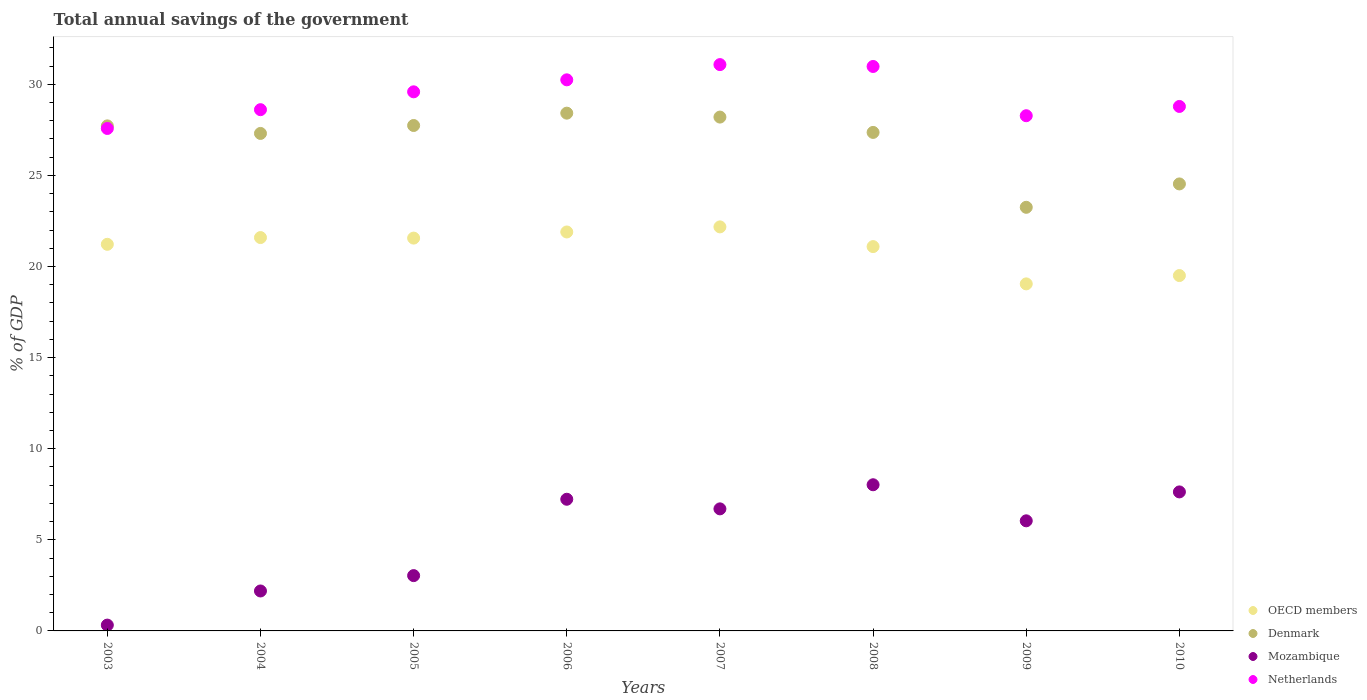How many different coloured dotlines are there?
Your response must be concise. 4. Is the number of dotlines equal to the number of legend labels?
Ensure brevity in your answer.  Yes. What is the total annual savings of the government in Netherlands in 2008?
Give a very brief answer. 30.98. Across all years, what is the maximum total annual savings of the government in OECD members?
Offer a very short reply. 22.17. Across all years, what is the minimum total annual savings of the government in Mozambique?
Offer a terse response. 0.32. What is the total total annual savings of the government in OECD members in the graph?
Your response must be concise. 168.07. What is the difference between the total annual savings of the government in Netherlands in 2004 and that in 2010?
Your answer should be compact. -0.18. What is the difference between the total annual savings of the government in Netherlands in 2006 and the total annual savings of the government in Mozambique in 2009?
Your answer should be very brief. 24.2. What is the average total annual savings of the government in OECD members per year?
Your answer should be compact. 21.01. In the year 2007, what is the difference between the total annual savings of the government in OECD members and total annual savings of the government in Denmark?
Make the answer very short. -6.03. In how many years, is the total annual savings of the government in Netherlands greater than 11 %?
Offer a terse response. 8. What is the ratio of the total annual savings of the government in Denmark in 2003 to that in 2004?
Your response must be concise. 1.02. What is the difference between the highest and the second highest total annual savings of the government in OECD members?
Provide a succinct answer. 0.28. What is the difference between the highest and the lowest total annual savings of the government in Denmark?
Offer a very short reply. 5.17. In how many years, is the total annual savings of the government in Mozambique greater than the average total annual savings of the government in Mozambique taken over all years?
Your answer should be compact. 5. Is it the case that in every year, the sum of the total annual savings of the government in Netherlands and total annual savings of the government in OECD members  is greater than the sum of total annual savings of the government in Mozambique and total annual savings of the government in Denmark?
Make the answer very short. No. Is it the case that in every year, the sum of the total annual savings of the government in Netherlands and total annual savings of the government in Denmark  is greater than the total annual savings of the government in OECD members?
Your response must be concise. Yes. Does the total annual savings of the government in Denmark monotonically increase over the years?
Give a very brief answer. No. Is the total annual savings of the government in Netherlands strictly less than the total annual savings of the government in OECD members over the years?
Your response must be concise. No. What is the difference between two consecutive major ticks on the Y-axis?
Provide a short and direct response. 5. Are the values on the major ticks of Y-axis written in scientific E-notation?
Offer a very short reply. No. Does the graph contain grids?
Your answer should be compact. No. How many legend labels are there?
Keep it short and to the point. 4. How are the legend labels stacked?
Keep it short and to the point. Vertical. What is the title of the graph?
Offer a very short reply. Total annual savings of the government. Does "Liechtenstein" appear as one of the legend labels in the graph?
Your answer should be very brief. No. What is the label or title of the X-axis?
Give a very brief answer. Years. What is the label or title of the Y-axis?
Your answer should be compact. % of GDP. What is the % of GDP of OECD members in 2003?
Keep it short and to the point. 21.22. What is the % of GDP in Denmark in 2003?
Your response must be concise. 27.72. What is the % of GDP of Mozambique in 2003?
Give a very brief answer. 0.32. What is the % of GDP of Netherlands in 2003?
Ensure brevity in your answer.  27.58. What is the % of GDP of OECD members in 2004?
Offer a very short reply. 21.59. What is the % of GDP of Denmark in 2004?
Keep it short and to the point. 27.3. What is the % of GDP of Mozambique in 2004?
Your response must be concise. 2.19. What is the % of GDP in Netherlands in 2004?
Offer a very short reply. 28.61. What is the % of GDP of OECD members in 2005?
Your response must be concise. 21.56. What is the % of GDP in Denmark in 2005?
Provide a succinct answer. 27.74. What is the % of GDP of Mozambique in 2005?
Your answer should be compact. 3.04. What is the % of GDP in Netherlands in 2005?
Ensure brevity in your answer.  29.59. What is the % of GDP of OECD members in 2006?
Offer a very short reply. 21.89. What is the % of GDP in Denmark in 2006?
Offer a very short reply. 28.42. What is the % of GDP in Mozambique in 2006?
Offer a very short reply. 7.23. What is the % of GDP in Netherlands in 2006?
Offer a terse response. 30.24. What is the % of GDP in OECD members in 2007?
Provide a succinct answer. 22.17. What is the % of GDP in Denmark in 2007?
Keep it short and to the point. 28.2. What is the % of GDP of Mozambique in 2007?
Provide a succinct answer. 6.7. What is the % of GDP in Netherlands in 2007?
Give a very brief answer. 31.08. What is the % of GDP in OECD members in 2008?
Provide a succinct answer. 21.09. What is the % of GDP of Denmark in 2008?
Your answer should be compact. 27.36. What is the % of GDP of Mozambique in 2008?
Keep it short and to the point. 8.02. What is the % of GDP of Netherlands in 2008?
Offer a terse response. 30.98. What is the % of GDP in OECD members in 2009?
Your answer should be very brief. 19.05. What is the % of GDP of Denmark in 2009?
Your answer should be very brief. 23.25. What is the % of GDP of Mozambique in 2009?
Keep it short and to the point. 6.04. What is the % of GDP in Netherlands in 2009?
Keep it short and to the point. 28.27. What is the % of GDP of OECD members in 2010?
Provide a succinct answer. 19.5. What is the % of GDP of Denmark in 2010?
Your answer should be compact. 24.53. What is the % of GDP of Mozambique in 2010?
Provide a succinct answer. 7.63. What is the % of GDP in Netherlands in 2010?
Keep it short and to the point. 28.78. Across all years, what is the maximum % of GDP in OECD members?
Provide a short and direct response. 22.17. Across all years, what is the maximum % of GDP in Denmark?
Keep it short and to the point. 28.42. Across all years, what is the maximum % of GDP of Mozambique?
Ensure brevity in your answer.  8.02. Across all years, what is the maximum % of GDP of Netherlands?
Provide a succinct answer. 31.08. Across all years, what is the minimum % of GDP of OECD members?
Make the answer very short. 19.05. Across all years, what is the minimum % of GDP of Denmark?
Provide a succinct answer. 23.25. Across all years, what is the minimum % of GDP in Mozambique?
Offer a terse response. 0.32. Across all years, what is the minimum % of GDP in Netherlands?
Give a very brief answer. 27.58. What is the total % of GDP of OECD members in the graph?
Your answer should be compact. 168.07. What is the total % of GDP in Denmark in the graph?
Give a very brief answer. 214.51. What is the total % of GDP in Mozambique in the graph?
Provide a succinct answer. 41.16. What is the total % of GDP of Netherlands in the graph?
Provide a short and direct response. 235.13. What is the difference between the % of GDP of OECD members in 2003 and that in 2004?
Keep it short and to the point. -0.37. What is the difference between the % of GDP in Denmark in 2003 and that in 2004?
Provide a succinct answer. 0.41. What is the difference between the % of GDP of Mozambique in 2003 and that in 2004?
Keep it short and to the point. -1.87. What is the difference between the % of GDP in Netherlands in 2003 and that in 2004?
Offer a very short reply. -1.03. What is the difference between the % of GDP of OECD members in 2003 and that in 2005?
Give a very brief answer. -0.34. What is the difference between the % of GDP in Denmark in 2003 and that in 2005?
Provide a succinct answer. -0.02. What is the difference between the % of GDP of Mozambique in 2003 and that in 2005?
Your answer should be very brief. -2.72. What is the difference between the % of GDP of Netherlands in 2003 and that in 2005?
Give a very brief answer. -2.01. What is the difference between the % of GDP in OECD members in 2003 and that in 2006?
Provide a succinct answer. -0.68. What is the difference between the % of GDP in Denmark in 2003 and that in 2006?
Your answer should be very brief. -0.7. What is the difference between the % of GDP of Mozambique in 2003 and that in 2006?
Your response must be concise. -6.91. What is the difference between the % of GDP in Netherlands in 2003 and that in 2006?
Make the answer very short. -2.67. What is the difference between the % of GDP of OECD members in 2003 and that in 2007?
Your answer should be compact. -0.96. What is the difference between the % of GDP in Denmark in 2003 and that in 2007?
Your response must be concise. -0.48. What is the difference between the % of GDP of Mozambique in 2003 and that in 2007?
Your response must be concise. -6.38. What is the difference between the % of GDP in Netherlands in 2003 and that in 2007?
Make the answer very short. -3.51. What is the difference between the % of GDP in OECD members in 2003 and that in 2008?
Keep it short and to the point. 0.13. What is the difference between the % of GDP of Denmark in 2003 and that in 2008?
Offer a very short reply. 0.36. What is the difference between the % of GDP in Mozambique in 2003 and that in 2008?
Offer a very short reply. -7.7. What is the difference between the % of GDP in Netherlands in 2003 and that in 2008?
Ensure brevity in your answer.  -3.4. What is the difference between the % of GDP in OECD members in 2003 and that in 2009?
Keep it short and to the point. 2.17. What is the difference between the % of GDP of Denmark in 2003 and that in 2009?
Make the answer very short. 4.47. What is the difference between the % of GDP in Mozambique in 2003 and that in 2009?
Provide a succinct answer. -5.72. What is the difference between the % of GDP in Netherlands in 2003 and that in 2009?
Offer a very short reply. -0.7. What is the difference between the % of GDP of OECD members in 2003 and that in 2010?
Offer a very short reply. 1.71. What is the difference between the % of GDP of Denmark in 2003 and that in 2010?
Make the answer very short. 3.19. What is the difference between the % of GDP in Mozambique in 2003 and that in 2010?
Provide a short and direct response. -7.31. What is the difference between the % of GDP in Netherlands in 2003 and that in 2010?
Provide a succinct answer. -1.21. What is the difference between the % of GDP in OECD members in 2004 and that in 2005?
Give a very brief answer. 0.03. What is the difference between the % of GDP in Denmark in 2004 and that in 2005?
Offer a terse response. -0.44. What is the difference between the % of GDP in Mozambique in 2004 and that in 2005?
Offer a very short reply. -0.84. What is the difference between the % of GDP of Netherlands in 2004 and that in 2005?
Give a very brief answer. -0.98. What is the difference between the % of GDP in OECD members in 2004 and that in 2006?
Your response must be concise. -0.31. What is the difference between the % of GDP of Denmark in 2004 and that in 2006?
Ensure brevity in your answer.  -1.11. What is the difference between the % of GDP in Mozambique in 2004 and that in 2006?
Make the answer very short. -5.03. What is the difference between the % of GDP of Netherlands in 2004 and that in 2006?
Your response must be concise. -1.64. What is the difference between the % of GDP in OECD members in 2004 and that in 2007?
Offer a very short reply. -0.59. What is the difference between the % of GDP in Denmark in 2004 and that in 2007?
Ensure brevity in your answer.  -0.9. What is the difference between the % of GDP of Mozambique in 2004 and that in 2007?
Your answer should be compact. -4.51. What is the difference between the % of GDP of Netherlands in 2004 and that in 2007?
Your answer should be very brief. -2.47. What is the difference between the % of GDP of OECD members in 2004 and that in 2008?
Give a very brief answer. 0.5. What is the difference between the % of GDP in Denmark in 2004 and that in 2008?
Your answer should be very brief. -0.06. What is the difference between the % of GDP of Mozambique in 2004 and that in 2008?
Your answer should be compact. -5.83. What is the difference between the % of GDP of Netherlands in 2004 and that in 2008?
Give a very brief answer. -2.37. What is the difference between the % of GDP in OECD members in 2004 and that in 2009?
Your response must be concise. 2.54. What is the difference between the % of GDP in Denmark in 2004 and that in 2009?
Make the answer very short. 4.05. What is the difference between the % of GDP in Mozambique in 2004 and that in 2009?
Offer a terse response. -3.85. What is the difference between the % of GDP in Netherlands in 2004 and that in 2009?
Ensure brevity in your answer.  0.33. What is the difference between the % of GDP in OECD members in 2004 and that in 2010?
Ensure brevity in your answer.  2.09. What is the difference between the % of GDP of Denmark in 2004 and that in 2010?
Provide a short and direct response. 2.77. What is the difference between the % of GDP in Mozambique in 2004 and that in 2010?
Make the answer very short. -5.44. What is the difference between the % of GDP of Netherlands in 2004 and that in 2010?
Provide a succinct answer. -0.18. What is the difference between the % of GDP in OECD members in 2005 and that in 2006?
Your answer should be compact. -0.34. What is the difference between the % of GDP of Denmark in 2005 and that in 2006?
Make the answer very short. -0.68. What is the difference between the % of GDP in Mozambique in 2005 and that in 2006?
Your answer should be very brief. -4.19. What is the difference between the % of GDP in Netherlands in 2005 and that in 2006?
Your response must be concise. -0.66. What is the difference between the % of GDP in OECD members in 2005 and that in 2007?
Your answer should be compact. -0.62. What is the difference between the % of GDP of Denmark in 2005 and that in 2007?
Make the answer very short. -0.46. What is the difference between the % of GDP of Mozambique in 2005 and that in 2007?
Keep it short and to the point. -3.66. What is the difference between the % of GDP of Netherlands in 2005 and that in 2007?
Ensure brevity in your answer.  -1.49. What is the difference between the % of GDP of OECD members in 2005 and that in 2008?
Provide a short and direct response. 0.47. What is the difference between the % of GDP of Denmark in 2005 and that in 2008?
Ensure brevity in your answer.  0.38. What is the difference between the % of GDP of Mozambique in 2005 and that in 2008?
Provide a short and direct response. -4.99. What is the difference between the % of GDP of Netherlands in 2005 and that in 2008?
Ensure brevity in your answer.  -1.39. What is the difference between the % of GDP of OECD members in 2005 and that in 2009?
Make the answer very short. 2.51. What is the difference between the % of GDP in Denmark in 2005 and that in 2009?
Your answer should be very brief. 4.49. What is the difference between the % of GDP in Mozambique in 2005 and that in 2009?
Provide a succinct answer. -3.01. What is the difference between the % of GDP of Netherlands in 2005 and that in 2009?
Offer a very short reply. 1.31. What is the difference between the % of GDP of OECD members in 2005 and that in 2010?
Provide a short and direct response. 2.06. What is the difference between the % of GDP in Denmark in 2005 and that in 2010?
Offer a terse response. 3.21. What is the difference between the % of GDP of Mozambique in 2005 and that in 2010?
Your answer should be very brief. -4.59. What is the difference between the % of GDP in Netherlands in 2005 and that in 2010?
Provide a succinct answer. 0.8. What is the difference between the % of GDP in OECD members in 2006 and that in 2007?
Give a very brief answer. -0.28. What is the difference between the % of GDP in Denmark in 2006 and that in 2007?
Your response must be concise. 0.22. What is the difference between the % of GDP of Mozambique in 2006 and that in 2007?
Ensure brevity in your answer.  0.53. What is the difference between the % of GDP of Netherlands in 2006 and that in 2007?
Provide a short and direct response. -0.84. What is the difference between the % of GDP in OECD members in 2006 and that in 2008?
Offer a very short reply. 0.8. What is the difference between the % of GDP in Denmark in 2006 and that in 2008?
Offer a terse response. 1.06. What is the difference between the % of GDP of Mozambique in 2006 and that in 2008?
Your answer should be very brief. -0.8. What is the difference between the % of GDP of Netherlands in 2006 and that in 2008?
Make the answer very short. -0.73. What is the difference between the % of GDP of OECD members in 2006 and that in 2009?
Your answer should be compact. 2.85. What is the difference between the % of GDP in Denmark in 2006 and that in 2009?
Your answer should be very brief. 5.17. What is the difference between the % of GDP in Mozambique in 2006 and that in 2009?
Your response must be concise. 1.18. What is the difference between the % of GDP of Netherlands in 2006 and that in 2009?
Offer a very short reply. 1.97. What is the difference between the % of GDP in OECD members in 2006 and that in 2010?
Ensure brevity in your answer.  2.39. What is the difference between the % of GDP in Denmark in 2006 and that in 2010?
Keep it short and to the point. 3.88. What is the difference between the % of GDP in Mozambique in 2006 and that in 2010?
Provide a short and direct response. -0.4. What is the difference between the % of GDP of Netherlands in 2006 and that in 2010?
Give a very brief answer. 1.46. What is the difference between the % of GDP in OECD members in 2007 and that in 2008?
Your answer should be compact. 1.08. What is the difference between the % of GDP in Denmark in 2007 and that in 2008?
Give a very brief answer. 0.84. What is the difference between the % of GDP in Mozambique in 2007 and that in 2008?
Make the answer very short. -1.32. What is the difference between the % of GDP of Netherlands in 2007 and that in 2008?
Provide a short and direct response. 0.1. What is the difference between the % of GDP of OECD members in 2007 and that in 2009?
Provide a short and direct response. 3.13. What is the difference between the % of GDP of Denmark in 2007 and that in 2009?
Offer a terse response. 4.95. What is the difference between the % of GDP of Mozambique in 2007 and that in 2009?
Give a very brief answer. 0.66. What is the difference between the % of GDP of Netherlands in 2007 and that in 2009?
Ensure brevity in your answer.  2.81. What is the difference between the % of GDP of OECD members in 2007 and that in 2010?
Your answer should be very brief. 2.67. What is the difference between the % of GDP of Denmark in 2007 and that in 2010?
Make the answer very short. 3.67. What is the difference between the % of GDP in Mozambique in 2007 and that in 2010?
Offer a terse response. -0.93. What is the difference between the % of GDP of Netherlands in 2007 and that in 2010?
Provide a short and direct response. 2.3. What is the difference between the % of GDP in OECD members in 2008 and that in 2009?
Provide a short and direct response. 2.05. What is the difference between the % of GDP in Denmark in 2008 and that in 2009?
Your response must be concise. 4.11. What is the difference between the % of GDP in Mozambique in 2008 and that in 2009?
Make the answer very short. 1.98. What is the difference between the % of GDP of Netherlands in 2008 and that in 2009?
Your response must be concise. 2.7. What is the difference between the % of GDP of OECD members in 2008 and that in 2010?
Offer a very short reply. 1.59. What is the difference between the % of GDP of Denmark in 2008 and that in 2010?
Give a very brief answer. 2.83. What is the difference between the % of GDP in Mozambique in 2008 and that in 2010?
Provide a short and direct response. 0.39. What is the difference between the % of GDP in Netherlands in 2008 and that in 2010?
Offer a very short reply. 2.19. What is the difference between the % of GDP of OECD members in 2009 and that in 2010?
Offer a very short reply. -0.46. What is the difference between the % of GDP of Denmark in 2009 and that in 2010?
Your response must be concise. -1.28. What is the difference between the % of GDP in Mozambique in 2009 and that in 2010?
Make the answer very short. -1.59. What is the difference between the % of GDP of Netherlands in 2009 and that in 2010?
Provide a short and direct response. -0.51. What is the difference between the % of GDP in OECD members in 2003 and the % of GDP in Denmark in 2004?
Your answer should be very brief. -6.09. What is the difference between the % of GDP of OECD members in 2003 and the % of GDP of Mozambique in 2004?
Give a very brief answer. 19.03. What is the difference between the % of GDP in OECD members in 2003 and the % of GDP in Netherlands in 2004?
Provide a short and direct response. -7.39. What is the difference between the % of GDP of Denmark in 2003 and the % of GDP of Mozambique in 2004?
Ensure brevity in your answer.  25.52. What is the difference between the % of GDP in Denmark in 2003 and the % of GDP in Netherlands in 2004?
Your response must be concise. -0.89. What is the difference between the % of GDP of Mozambique in 2003 and the % of GDP of Netherlands in 2004?
Offer a very short reply. -28.29. What is the difference between the % of GDP of OECD members in 2003 and the % of GDP of Denmark in 2005?
Give a very brief answer. -6.52. What is the difference between the % of GDP in OECD members in 2003 and the % of GDP in Mozambique in 2005?
Ensure brevity in your answer.  18.18. What is the difference between the % of GDP of OECD members in 2003 and the % of GDP of Netherlands in 2005?
Give a very brief answer. -8.37. What is the difference between the % of GDP of Denmark in 2003 and the % of GDP of Mozambique in 2005?
Provide a short and direct response. 24.68. What is the difference between the % of GDP of Denmark in 2003 and the % of GDP of Netherlands in 2005?
Your response must be concise. -1.87. What is the difference between the % of GDP in Mozambique in 2003 and the % of GDP in Netherlands in 2005?
Give a very brief answer. -29.27. What is the difference between the % of GDP of OECD members in 2003 and the % of GDP of Denmark in 2006?
Keep it short and to the point. -7.2. What is the difference between the % of GDP in OECD members in 2003 and the % of GDP in Mozambique in 2006?
Offer a very short reply. 13.99. What is the difference between the % of GDP of OECD members in 2003 and the % of GDP of Netherlands in 2006?
Your answer should be very brief. -9.03. What is the difference between the % of GDP of Denmark in 2003 and the % of GDP of Mozambique in 2006?
Provide a short and direct response. 20.49. What is the difference between the % of GDP of Denmark in 2003 and the % of GDP of Netherlands in 2006?
Offer a terse response. -2.53. What is the difference between the % of GDP of Mozambique in 2003 and the % of GDP of Netherlands in 2006?
Ensure brevity in your answer.  -29.92. What is the difference between the % of GDP of OECD members in 2003 and the % of GDP of Denmark in 2007?
Your answer should be very brief. -6.98. What is the difference between the % of GDP in OECD members in 2003 and the % of GDP in Mozambique in 2007?
Ensure brevity in your answer.  14.52. What is the difference between the % of GDP of OECD members in 2003 and the % of GDP of Netherlands in 2007?
Your answer should be compact. -9.86. What is the difference between the % of GDP in Denmark in 2003 and the % of GDP in Mozambique in 2007?
Provide a short and direct response. 21.02. What is the difference between the % of GDP in Denmark in 2003 and the % of GDP in Netherlands in 2007?
Ensure brevity in your answer.  -3.36. What is the difference between the % of GDP of Mozambique in 2003 and the % of GDP of Netherlands in 2007?
Ensure brevity in your answer.  -30.76. What is the difference between the % of GDP of OECD members in 2003 and the % of GDP of Denmark in 2008?
Give a very brief answer. -6.14. What is the difference between the % of GDP in OECD members in 2003 and the % of GDP in Mozambique in 2008?
Give a very brief answer. 13.2. What is the difference between the % of GDP of OECD members in 2003 and the % of GDP of Netherlands in 2008?
Your answer should be very brief. -9.76. What is the difference between the % of GDP of Denmark in 2003 and the % of GDP of Mozambique in 2008?
Keep it short and to the point. 19.7. What is the difference between the % of GDP in Denmark in 2003 and the % of GDP in Netherlands in 2008?
Provide a short and direct response. -3.26. What is the difference between the % of GDP in Mozambique in 2003 and the % of GDP in Netherlands in 2008?
Provide a short and direct response. -30.66. What is the difference between the % of GDP of OECD members in 2003 and the % of GDP of Denmark in 2009?
Make the answer very short. -2.03. What is the difference between the % of GDP of OECD members in 2003 and the % of GDP of Mozambique in 2009?
Provide a short and direct response. 15.17. What is the difference between the % of GDP in OECD members in 2003 and the % of GDP in Netherlands in 2009?
Your answer should be very brief. -7.06. What is the difference between the % of GDP of Denmark in 2003 and the % of GDP of Mozambique in 2009?
Your answer should be very brief. 21.67. What is the difference between the % of GDP in Denmark in 2003 and the % of GDP in Netherlands in 2009?
Offer a very short reply. -0.56. What is the difference between the % of GDP in Mozambique in 2003 and the % of GDP in Netherlands in 2009?
Offer a terse response. -27.95. What is the difference between the % of GDP of OECD members in 2003 and the % of GDP of Denmark in 2010?
Your response must be concise. -3.31. What is the difference between the % of GDP in OECD members in 2003 and the % of GDP in Mozambique in 2010?
Make the answer very short. 13.59. What is the difference between the % of GDP in OECD members in 2003 and the % of GDP in Netherlands in 2010?
Provide a succinct answer. -7.57. What is the difference between the % of GDP of Denmark in 2003 and the % of GDP of Mozambique in 2010?
Provide a short and direct response. 20.09. What is the difference between the % of GDP in Denmark in 2003 and the % of GDP in Netherlands in 2010?
Provide a succinct answer. -1.07. What is the difference between the % of GDP of Mozambique in 2003 and the % of GDP of Netherlands in 2010?
Your answer should be very brief. -28.46. What is the difference between the % of GDP in OECD members in 2004 and the % of GDP in Denmark in 2005?
Provide a short and direct response. -6.15. What is the difference between the % of GDP in OECD members in 2004 and the % of GDP in Mozambique in 2005?
Offer a very short reply. 18.55. What is the difference between the % of GDP in OECD members in 2004 and the % of GDP in Netherlands in 2005?
Ensure brevity in your answer.  -8. What is the difference between the % of GDP in Denmark in 2004 and the % of GDP in Mozambique in 2005?
Provide a succinct answer. 24.27. What is the difference between the % of GDP of Denmark in 2004 and the % of GDP of Netherlands in 2005?
Your answer should be very brief. -2.28. What is the difference between the % of GDP in Mozambique in 2004 and the % of GDP in Netherlands in 2005?
Keep it short and to the point. -27.39. What is the difference between the % of GDP of OECD members in 2004 and the % of GDP of Denmark in 2006?
Provide a succinct answer. -6.83. What is the difference between the % of GDP in OECD members in 2004 and the % of GDP in Mozambique in 2006?
Offer a very short reply. 14.36. What is the difference between the % of GDP in OECD members in 2004 and the % of GDP in Netherlands in 2006?
Offer a very short reply. -8.66. What is the difference between the % of GDP in Denmark in 2004 and the % of GDP in Mozambique in 2006?
Give a very brief answer. 20.08. What is the difference between the % of GDP of Denmark in 2004 and the % of GDP of Netherlands in 2006?
Your response must be concise. -2.94. What is the difference between the % of GDP in Mozambique in 2004 and the % of GDP in Netherlands in 2006?
Ensure brevity in your answer.  -28.05. What is the difference between the % of GDP in OECD members in 2004 and the % of GDP in Denmark in 2007?
Provide a succinct answer. -6.61. What is the difference between the % of GDP of OECD members in 2004 and the % of GDP of Mozambique in 2007?
Offer a very short reply. 14.89. What is the difference between the % of GDP in OECD members in 2004 and the % of GDP in Netherlands in 2007?
Make the answer very short. -9.49. What is the difference between the % of GDP in Denmark in 2004 and the % of GDP in Mozambique in 2007?
Provide a short and direct response. 20.6. What is the difference between the % of GDP in Denmark in 2004 and the % of GDP in Netherlands in 2007?
Ensure brevity in your answer.  -3.78. What is the difference between the % of GDP of Mozambique in 2004 and the % of GDP of Netherlands in 2007?
Offer a terse response. -28.89. What is the difference between the % of GDP of OECD members in 2004 and the % of GDP of Denmark in 2008?
Keep it short and to the point. -5.77. What is the difference between the % of GDP in OECD members in 2004 and the % of GDP in Mozambique in 2008?
Offer a terse response. 13.57. What is the difference between the % of GDP of OECD members in 2004 and the % of GDP of Netherlands in 2008?
Offer a very short reply. -9.39. What is the difference between the % of GDP of Denmark in 2004 and the % of GDP of Mozambique in 2008?
Offer a terse response. 19.28. What is the difference between the % of GDP in Denmark in 2004 and the % of GDP in Netherlands in 2008?
Your response must be concise. -3.67. What is the difference between the % of GDP in Mozambique in 2004 and the % of GDP in Netherlands in 2008?
Make the answer very short. -28.79. What is the difference between the % of GDP in OECD members in 2004 and the % of GDP in Denmark in 2009?
Keep it short and to the point. -1.66. What is the difference between the % of GDP of OECD members in 2004 and the % of GDP of Mozambique in 2009?
Offer a terse response. 15.55. What is the difference between the % of GDP in OECD members in 2004 and the % of GDP in Netherlands in 2009?
Your answer should be compact. -6.69. What is the difference between the % of GDP in Denmark in 2004 and the % of GDP in Mozambique in 2009?
Keep it short and to the point. 21.26. What is the difference between the % of GDP of Denmark in 2004 and the % of GDP of Netherlands in 2009?
Ensure brevity in your answer.  -0.97. What is the difference between the % of GDP in Mozambique in 2004 and the % of GDP in Netherlands in 2009?
Give a very brief answer. -26.08. What is the difference between the % of GDP in OECD members in 2004 and the % of GDP in Denmark in 2010?
Keep it short and to the point. -2.94. What is the difference between the % of GDP of OECD members in 2004 and the % of GDP of Mozambique in 2010?
Offer a very short reply. 13.96. What is the difference between the % of GDP in OECD members in 2004 and the % of GDP in Netherlands in 2010?
Provide a short and direct response. -7.2. What is the difference between the % of GDP of Denmark in 2004 and the % of GDP of Mozambique in 2010?
Provide a short and direct response. 19.67. What is the difference between the % of GDP in Denmark in 2004 and the % of GDP in Netherlands in 2010?
Provide a succinct answer. -1.48. What is the difference between the % of GDP of Mozambique in 2004 and the % of GDP of Netherlands in 2010?
Your answer should be very brief. -26.59. What is the difference between the % of GDP in OECD members in 2005 and the % of GDP in Denmark in 2006?
Offer a very short reply. -6.86. What is the difference between the % of GDP in OECD members in 2005 and the % of GDP in Mozambique in 2006?
Offer a very short reply. 14.33. What is the difference between the % of GDP of OECD members in 2005 and the % of GDP of Netherlands in 2006?
Keep it short and to the point. -8.69. What is the difference between the % of GDP of Denmark in 2005 and the % of GDP of Mozambique in 2006?
Make the answer very short. 20.51. What is the difference between the % of GDP of Denmark in 2005 and the % of GDP of Netherlands in 2006?
Offer a very short reply. -2.51. What is the difference between the % of GDP of Mozambique in 2005 and the % of GDP of Netherlands in 2006?
Your answer should be compact. -27.21. What is the difference between the % of GDP in OECD members in 2005 and the % of GDP in Denmark in 2007?
Your answer should be very brief. -6.64. What is the difference between the % of GDP of OECD members in 2005 and the % of GDP of Mozambique in 2007?
Give a very brief answer. 14.86. What is the difference between the % of GDP of OECD members in 2005 and the % of GDP of Netherlands in 2007?
Offer a very short reply. -9.52. What is the difference between the % of GDP of Denmark in 2005 and the % of GDP of Mozambique in 2007?
Ensure brevity in your answer.  21.04. What is the difference between the % of GDP in Denmark in 2005 and the % of GDP in Netherlands in 2007?
Your response must be concise. -3.34. What is the difference between the % of GDP in Mozambique in 2005 and the % of GDP in Netherlands in 2007?
Provide a succinct answer. -28.05. What is the difference between the % of GDP in OECD members in 2005 and the % of GDP in Denmark in 2008?
Your answer should be very brief. -5.8. What is the difference between the % of GDP in OECD members in 2005 and the % of GDP in Mozambique in 2008?
Your response must be concise. 13.54. What is the difference between the % of GDP in OECD members in 2005 and the % of GDP in Netherlands in 2008?
Your answer should be very brief. -9.42. What is the difference between the % of GDP of Denmark in 2005 and the % of GDP of Mozambique in 2008?
Give a very brief answer. 19.72. What is the difference between the % of GDP in Denmark in 2005 and the % of GDP in Netherlands in 2008?
Ensure brevity in your answer.  -3.24. What is the difference between the % of GDP in Mozambique in 2005 and the % of GDP in Netherlands in 2008?
Offer a very short reply. -27.94. What is the difference between the % of GDP of OECD members in 2005 and the % of GDP of Denmark in 2009?
Offer a very short reply. -1.69. What is the difference between the % of GDP of OECD members in 2005 and the % of GDP of Mozambique in 2009?
Your answer should be compact. 15.52. What is the difference between the % of GDP of OECD members in 2005 and the % of GDP of Netherlands in 2009?
Your answer should be compact. -6.72. What is the difference between the % of GDP of Denmark in 2005 and the % of GDP of Mozambique in 2009?
Ensure brevity in your answer.  21.7. What is the difference between the % of GDP in Denmark in 2005 and the % of GDP in Netherlands in 2009?
Your answer should be very brief. -0.54. What is the difference between the % of GDP of Mozambique in 2005 and the % of GDP of Netherlands in 2009?
Offer a terse response. -25.24. What is the difference between the % of GDP in OECD members in 2005 and the % of GDP in Denmark in 2010?
Provide a succinct answer. -2.97. What is the difference between the % of GDP of OECD members in 2005 and the % of GDP of Mozambique in 2010?
Give a very brief answer. 13.93. What is the difference between the % of GDP in OECD members in 2005 and the % of GDP in Netherlands in 2010?
Offer a very short reply. -7.23. What is the difference between the % of GDP of Denmark in 2005 and the % of GDP of Mozambique in 2010?
Your answer should be very brief. 20.11. What is the difference between the % of GDP of Denmark in 2005 and the % of GDP of Netherlands in 2010?
Give a very brief answer. -1.05. What is the difference between the % of GDP of Mozambique in 2005 and the % of GDP of Netherlands in 2010?
Your answer should be compact. -25.75. What is the difference between the % of GDP of OECD members in 2006 and the % of GDP of Denmark in 2007?
Ensure brevity in your answer.  -6.31. What is the difference between the % of GDP in OECD members in 2006 and the % of GDP in Mozambique in 2007?
Make the answer very short. 15.2. What is the difference between the % of GDP in OECD members in 2006 and the % of GDP in Netherlands in 2007?
Make the answer very short. -9.19. What is the difference between the % of GDP in Denmark in 2006 and the % of GDP in Mozambique in 2007?
Give a very brief answer. 21.72. What is the difference between the % of GDP of Denmark in 2006 and the % of GDP of Netherlands in 2007?
Make the answer very short. -2.67. What is the difference between the % of GDP in Mozambique in 2006 and the % of GDP in Netherlands in 2007?
Provide a succinct answer. -23.85. What is the difference between the % of GDP in OECD members in 2006 and the % of GDP in Denmark in 2008?
Give a very brief answer. -5.46. What is the difference between the % of GDP of OECD members in 2006 and the % of GDP of Mozambique in 2008?
Provide a succinct answer. 13.87. What is the difference between the % of GDP of OECD members in 2006 and the % of GDP of Netherlands in 2008?
Give a very brief answer. -9.08. What is the difference between the % of GDP of Denmark in 2006 and the % of GDP of Mozambique in 2008?
Offer a terse response. 20.39. What is the difference between the % of GDP of Denmark in 2006 and the % of GDP of Netherlands in 2008?
Provide a short and direct response. -2.56. What is the difference between the % of GDP in Mozambique in 2006 and the % of GDP in Netherlands in 2008?
Your response must be concise. -23.75. What is the difference between the % of GDP of OECD members in 2006 and the % of GDP of Denmark in 2009?
Give a very brief answer. -1.35. What is the difference between the % of GDP of OECD members in 2006 and the % of GDP of Mozambique in 2009?
Your answer should be compact. 15.85. What is the difference between the % of GDP of OECD members in 2006 and the % of GDP of Netherlands in 2009?
Provide a short and direct response. -6.38. What is the difference between the % of GDP in Denmark in 2006 and the % of GDP in Mozambique in 2009?
Your answer should be very brief. 22.37. What is the difference between the % of GDP in Denmark in 2006 and the % of GDP in Netherlands in 2009?
Your answer should be very brief. 0.14. What is the difference between the % of GDP of Mozambique in 2006 and the % of GDP of Netherlands in 2009?
Make the answer very short. -21.05. What is the difference between the % of GDP of OECD members in 2006 and the % of GDP of Denmark in 2010?
Provide a short and direct response. -2.64. What is the difference between the % of GDP in OECD members in 2006 and the % of GDP in Mozambique in 2010?
Offer a very short reply. 14.27. What is the difference between the % of GDP in OECD members in 2006 and the % of GDP in Netherlands in 2010?
Offer a very short reply. -6.89. What is the difference between the % of GDP in Denmark in 2006 and the % of GDP in Mozambique in 2010?
Your answer should be compact. 20.79. What is the difference between the % of GDP of Denmark in 2006 and the % of GDP of Netherlands in 2010?
Your response must be concise. -0.37. What is the difference between the % of GDP of Mozambique in 2006 and the % of GDP of Netherlands in 2010?
Ensure brevity in your answer.  -21.56. What is the difference between the % of GDP in OECD members in 2007 and the % of GDP in Denmark in 2008?
Offer a terse response. -5.18. What is the difference between the % of GDP of OECD members in 2007 and the % of GDP of Mozambique in 2008?
Offer a very short reply. 14.15. What is the difference between the % of GDP in OECD members in 2007 and the % of GDP in Netherlands in 2008?
Provide a short and direct response. -8.8. What is the difference between the % of GDP of Denmark in 2007 and the % of GDP of Mozambique in 2008?
Keep it short and to the point. 20.18. What is the difference between the % of GDP in Denmark in 2007 and the % of GDP in Netherlands in 2008?
Provide a succinct answer. -2.78. What is the difference between the % of GDP in Mozambique in 2007 and the % of GDP in Netherlands in 2008?
Make the answer very short. -24.28. What is the difference between the % of GDP in OECD members in 2007 and the % of GDP in Denmark in 2009?
Offer a terse response. -1.07. What is the difference between the % of GDP of OECD members in 2007 and the % of GDP of Mozambique in 2009?
Give a very brief answer. 16.13. What is the difference between the % of GDP in OECD members in 2007 and the % of GDP in Netherlands in 2009?
Your response must be concise. -6.1. What is the difference between the % of GDP of Denmark in 2007 and the % of GDP of Mozambique in 2009?
Your answer should be compact. 22.16. What is the difference between the % of GDP in Denmark in 2007 and the % of GDP in Netherlands in 2009?
Ensure brevity in your answer.  -0.07. What is the difference between the % of GDP in Mozambique in 2007 and the % of GDP in Netherlands in 2009?
Offer a terse response. -21.58. What is the difference between the % of GDP in OECD members in 2007 and the % of GDP in Denmark in 2010?
Provide a succinct answer. -2.36. What is the difference between the % of GDP in OECD members in 2007 and the % of GDP in Mozambique in 2010?
Offer a terse response. 14.55. What is the difference between the % of GDP of OECD members in 2007 and the % of GDP of Netherlands in 2010?
Your answer should be very brief. -6.61. What is the difference between the % of GDP in Denmark in 2007 and the % of GDP in Mozambique in 2010?
Give a very brief answer. 20.57. What is the difference between the % of GDP in Denmark in 2007 and the % of GDP in Netherlands in 2010?
Your answer should be very brief. -0.58. What is the difference between the % of GDP of Mozambique in 2007 and the % of GDP of Netherlands in 2010?
Your answer should be compact. -22.08. What is the difference between the % of GDP of OECD members in 2008 and the % of GDP of Denmark in 2009?
Provide a short and direct response. -2.16. What is the difference between the % of GDP of OECD members in 2008 and the % of GDP of Mozambique in 2009?
Your answer should be compact. 15.05. What is the difference between the % of GDP of OECD members in 2008 and the % of GDP of Netherlands in 2009?
Your response must be concise. -7.18. What is the difference between the % of GDP of Denmark in 2008 and the % of GDP of Mozambique in 2009?
Offer a very short reply. 21.32. What is the difference between the % of GDP of Denmark in 2008 and the % of GDP of Netherlands in 2009?
Offer a terse response. -0.92. What is the difference between the % of GDP in Mozambique in 2008 and the % of GDP in Netherlands in 2009?
Your answer should be very brief. -20.25. What is the difference between the % of GDP in OECD members in 2008 and the % of GDP in Denmark in 2010?
Provide a succinct answer. -3.44. What is the difference between the % of GDP in OECD members in 2008 and the % of GDP in Mozambique in 2010?
Make the answer very short. 13.46. What is the difference between the % of GDP of OECD members in 2008 and the % of GDP of Netherlands in 2010?
Make the answer very short. -7.69. What is the difference between the % of GDP of Denmark in 2008 and the % of GDP of Mozambique in 2010?
Your answer should be very brief. 19.73. What is the difference between the % of GDP of Denmark in 2008 and the % of GDP of Netherlands in 2010?
Your response must be concise. -1.43. What is the difference between the % of GDP in Mozambique in 2008 and the % of GDP in Netherlands in 2010?
Provide a short and direct response. -20.76. What is the difference between the % of GDP of OECD members in 2009 and the % of GDP of Denmark in 2010?
Offer a very short reply. -5.49. What is the difference between the % of GDP in OECD members in 2009 and the % of GDP in Mozambique in 2010?
Provide a succinct answer. 11.42. What is the difference between the % of GDP in OECD members in 2009 and the % of GDP in Netherlands in 2010?
Your answer should be very brief. -9.74. What is the difference between the % of GDP of Denmark in 2009 and the % of GDP of Mozambique in 2010?
Your answer should be very brief. 15.62. What is the difference between the % of GDP in Denmark in 2009 and the % of GDP in Netherlands in 2010?
Provide a succinct answer. -5.53. What is the difference between the % of GDP in Mozambique in 2009 and the % of GDP in Netherlands in 2010?
Give a very brief answer. -22.74. What is the average % of GDP of OECD members per year?
Provide a succinct answer. 21.01. What is the average % of GDP in Denmark per year?
Your answer should be very brief. 26.81. What is the average % of GDP of Mozambique per year?
Provide a short and direct response. 5.15. What is the average % of GDP in Netherlands per year?
Offer a very short reply. 29.39. In the year 2003, what is the difference between the % of GDP in OECD members and % of GDP in Denmark?
Give a very brief answer. -6.5. In the year 2003, what is the difference between the % of GDP in OECD members and % of GDP in Mozambique?
Provide a short and direct response. 20.9. In the year 2003, what is the difference between the % of GDP in OECD members and % of GDP in Netherlands?
Your answer should be very brief. -6.36. In the year 2003, what is the difference between the % of GDP of Denmark and % of GDP of Mozambique?
Offer a very short reply. 27.4. In the year 2003, what is the difference between the % of GDP in Denmark and % of GDP in Netherlands?
Your answer should be compact. 0.14. In the year 2003, what is the difference between the % of GDP in Mozambique and % of GDP in Netherlands?
Provide a short and direct response. -27.26. In the year 2004, what is the difference between the % of GDP in OECD members and % of GDP in Denmark?
Keep it short and to the point. -5.71. In the year 2004, what is the difference between the % of GDP in OECD members and % of GDP in Mozambique?
Keep it short and to the point. 19.4. In the year 2004, what is the difference between the % of GDP of OECD members and % of GDP of Netherlands?
Make the answer very short. -7.02. In the year 2004, what is the difference between the % of GDP in Denmark and % of GDP in Mozambique?
Give a very brief answer. 25.11. In the year 2004, what is the difference between the % of GDP of Denmark and % of GDP of Netherlands?
Ensure brevity in your answer.  -1.3. In the year 2004, what is the difference between the % of GDP of Mozambique and % of GDP of Netherlands?
Provide a succinct answer. -26.41. In the year 2005, what is the difference between the % of GDP of OECD members and % of GDP of Denmark?
Keep it short and to the point. -6.18. In the year 2005, what is the difference between the % of GDP of OECD members and % of GDP of Mozambique?
Your response must be concise. 18.52. In the year 2005, what is the difference between the % of GDP in OECD members and % of GDP in Netherlands?
Keep it short and to the point. -8.03. In the year 2005, what is the difference between the % of GDP in Denmark and % of GDP in Mozambique?
Provide a short and direct response. 24.7. In the year 2005, what is the difference between the % of GDP of Denmark and % of GDP of Netherlands?
Make the answer very short. -1.85. In the year 2005, what is the difference between the % of GDP in Mozambique and % of GDP in Netherlands?
Your answer should be very brief. -26.55. In the year 2006, what is the difference between the % of GDP of OECD members and % of GDP of Denmark?
Provide a short and direct response. -6.52. In the year 2006, what is the difference between the % of GDP in OECD members and % of GDP in Mozambique?
Make the answer very short. 14.67. In the year 2006, what is the difference between the % of GDP in OECD members and % of GDP in Netherlands?
Your response must be concise. -8.35. In the year 2006, what is the difference between the % of GDP in Denmark and % of GDP in Mozambique?
Your answer should be very brief. 21.19. In the year 2006, what is the difference between the % of GDP in Denmark and % of GDP in Netherlands?
Make the answer very short. -1.83. In the year 2006, what is the difference between the % of GDP of Mozambique and % of GDP of Netherlands?
Your answer should be very brief. -23.02. In the year 2007, what is the difference between the % of GDP of OECD members and % of GDP of Denmark?
Offer a very short reply. -6.03. In the year 2007, what is the difference between the % of GDP of OECD members and % of GDP of Mozambique?
Ensure brevity in your answer.  15.48. In the year 2007, what is the difference between the % of GDP in OECD members and % of GDP in Netherlands?
Provide a short and direct response. -8.91. In the year 2007, what is the difference between the % of GDP of Denmark and % of GDP of Mozambique?
Your answer should be very brief. 21.5. In the year 2007, what is the difference between the % of GDP of Denmark and % of GDP of Netherlands?
Offer a terse response. -2.88. In the year 2007, what is the difference between the % of GDP in Mozambique and % of GDP in Netherlands?
Give a very brief answer. -24.38. In the year 2008, what is the difference between the % of GDP of OECD members and % of GDP of Denmark?
Offer a terse response. -6.27. In the year 2008, what is the difference between the % of GDP in OECD members and % of GDP in Mozambique?
Offer a terse response. 13.07. In the year 2008, what is the difference between the % of GDP in OECD members and % of GDP in Netherlands?
Provide a succinct answer. -9.89. In the year 2008, what is the difference between the % of GDP of Denmark and % of GDP of Mozambique?
Ensure brevity in your answer.  19.34. In the year 2008, what is the difference between the % of GDP of Denmark and % of GDP of Netherlands?
Your answer should be compact. -3.62. In the year 2008, what is the difference between the % of GDP of Mozambique and % of GDP of Netherlands?
Keep it short and to the point. -22.96. In the year 2009, what is the difference between the % of GDP of OECD members and % of GDP of Denmark?
Your answer should be very brief. -4.2. In the year 2009, what is the difference between the % of GDP of OECD members and % of GDP of Mozambique?
Ensure brevity in your answer.  13. In the year 2009, what is the difference between the % of GDP in OECD members and % of GDP in Netherlands?
Your answer should be very brief. -9.23. In the year 2009, what is the difference between the % of GDP in Denmark and % of GDP in Mozambique?
Ensure brevity in your answer.  17.21. In the year 2009, what is the difference between the % of GDP in Denmark and % of GDP in Netherlands?
Ensure brevity in your answer.  -5.03. In the year 2009, what is the difference between the % of GDP in Mozambique and % of GDP in Netherlands?
Ensure brevity in your answer.  -22.23. In the year 2010, what is the difference between the % of GDP of OECD members and % of GDP of Denmark?
Offer a very short reply. -5.03. In the year 2010, what is the difference between the % of GDP of OECD members and % of GDP of Mozambique?
Your response must be concise. 11.87. In the year 2010, what is the difference between the % of GDP of OECD members and % of GDP of Netherlands?
Offer a terse response. -9.28. In the year 2010, what is the difference between the % of GDP in Denmark and % of GDP in Mozambique?
Keep it short and to the point. 16.9. In the year 2010, what is the difference between the % of GDP of Denmark and % of GDP of Netherlands?
Your response must be concise. -4.25. In the year 2010, what is the difference between the % of GDP of Mozambique and % of GDP of Netherlands?
Offer a terse response. -21.15. What is the ratio of the % of GDP in OECD members in 2003 to that in 2004?
Provide a short and direct response. 0.98. What is the ratio of the % of GDP of Denmark in 2003 to that in 2004?
Keep it short and to the point. 1.02. What is the ratio of the % of GDP in Mozambique in 2003 to that in 2004?
Make the answer very short. 0.15. What is the ratio of the % of GDP of Netherlands in 2003 to that in 2004?
Your answer should be compact. 0.96. What is the ratio of the % of GDP in OECD members in 2003 to that in 2005?
Keep it short and to the point. 0.98. What is the ratio of the % of GDP in Denmark in 2003 to that in 2005?
Your answer should be compact. 1. What is the ratio of the % of GDP of Mozambique in 2003 to that in 2005?
Keep it short and to the point. 0.11. What is the ratio of the % of GDP of Netherlands in 2003 to that in 2005?
Give a very brief answer. 0.93. What is the ratio of the % of GDP in OECD members in 2003 to that in 2006?
Make the answer very short. 0.97. What is the ratio of the % of GDP of Denmark in 2003 to that in 2006?
Make the answer very short. 0.98. What is the ratio of the % of GDP of Mozambique in 2003 to that in 2006?
Offer a terse response. 0.04. What is the ratio of the % of GDP in Netherlands in 2003 to that in 2006?
Ensure brevity in your answer.  0.91. What is the ratio of the % of GDP in OECD members in 2003 to that in 2007?
Your response must be concise. 0.96. What is the ratio of the % of GDP in Denmark in 2003 to that in 2007?
Offer a very short reply. 0.98. What is the ratio of the % of GDP in Mozambique in 2003 to that in 2007?
Ensure brevity in your answer.  0.05. What is the ratio of the % of GDP of Netherlands in 2003 to that in 2007?
Provide a succinct answer. 0.89. What is the ratio of the % of GDP in OECD members in 2003 to that in 2008?
Your answer should be very brief. 1.01. What is the ratio of the % of GDP of Denmark in 2003 to that in 2008?
Offer a very short reply. 1.01. What is the ratio of the % of GDP of Mozambique in 2003 to that in 2008?
Offer a terse response. 0.04. What is the ratio of the % of GDP in Netherlands in 2003 to that in 2008?
Provide a succinct answer. 0.89. What is the ratio of the % of GDP in OECD members in 2003 to that in 2009?
Keep it short and to the point. 1.11. What is the ratio of the % of GDP in Denmark in 2003 to that in 2009?
Make the answer very short. 1.19. What is the ratio of the % of GDP of Mozambique in 2003 to that in 2009?
Ensure brevity in your answer.  0.05. What is the ratio of the % of GDP in Netherlands in 2003 to that in 2009?
Provide a succinct answer. 0.98. What is the ratio of the % of GDP in OECD members in 2003 to that in 2010?
Give a very brief answer. 1.09. What is the ratio of the % of GDP of Denmark in 2003 to that in 2010?
Provide a short and direct response. 1.13. What is the ratio of the % of GDP of Mozambique in 2003 to that in 2010?
Your answer should be very brief. 0.04. What is the ratio of the % of GDP in Netherlands in 2003 to that in 2010?
Ensure brevity in your answer.  0.96. What is the ratio of the % of GDP in Denmark in 2004 to that in 2005?
Keep it short and to the point. 0.98. What is the ratio of the % of GDP in Mozambique in 2004 to that in 2005?
Your answer should be compact. 0.72. What is the ratio of the % of GDP in Netherlands in 2004 to that in 2005?
Offer a terse response. 0.97. What is the ratio of the % of GDP in OECD members in 2004 to that in 2006?
Make the answer very short. 0.99. What is the ratio of the % of GDP of Denmark in 2004 to that in 2006?
Offer a very short reply. 0.96. What is the ratio of the % of GDP in Mozambique in 2004 to that in 2006?
Provide a short and direct response. 0.3. What is the ratio of the % of GDP in Netherlands in 2004 to that in 2006?
Your answer should be very brief. 0.95. What is the ratio of the % of GDP of OECD members in 2004 to that in 2007?
Make the answer very short. 0.97. What is the ratio of the % of GDP of Denmark in 2004 to that in 2007?
Your answer should be compact. 0.97. What is the ratio of the % of GDP in Mozambique in 2004 to that in 2007?
Ensure brevity in your answer.  0.33. What is the ratio of the % of GDP in Netherlands in 2004 to that in 2007?
Provide a short and direct response. 0.92. What is the ratio of the % of GDP in OECD members in 2004 to that in 2008?
Your response must be concise. 1.02. What is the ratio of the % of GDP of Denmark in 2004 to that in 2008?
Your answer should be compact. 1. What is the ratio of the % of GDP in Mozambique in 2004 to that in 2008?
Give a very brief answer. 0.27. What is the ratio of the % of GDP in Netherlands in 2004 to that in 2008?
Your response must be concise. 0.92. What is the ratio of the % of GDP in OECD members in 2004 to that in 2009?
Provide a succinct answer. 1.13. What is the ratio of the % of GDP of Denmark in 2004 to that in 2009?
Offer a terse response. 1.17. What is the ratio of the % of GDP of Mozambique in 2004 to that in 2009?
Ensure brevity in your answer.  0.36. What is the ratio of the % of GDP of Netherlands in 2004 to that in 2009?
Keep it short and to the point. 1.01. What is the ratio of the % of GDP in OECD members in 2004 to that in 2010?
Keep it short and to the point. 1.11. What is the ratio of the % of GDP of Denmark in 2004 to that in 2010?
Make the answer very short. 1.11. What is the ratio of the % of GDP of Mozambique in 2004 to that in 2010?
Give a very brief answer. 0.29. What is the ratio of the % of GDP in OECD members in 2005 to that in 2006?
Make the answer very short. 0.98. What is the ratio of the % of GDP in Denmark in 2005 to that in 2006?
Make the answer very short. 0.98. What is the ratio of the % of GDP of Mozambique in 2005 to that in 2006?
Provide a short and direct response. 0.42. What is the ratio of the % of GDP of Netherlands in 2005 to that in 2006?
Provide a succinct answer. 0.98. What is the ratio of the % of GDP in OECD members in 2005 to that in 2007?
Keep it short and to the point. 0.97. What is the ratio of the % of GDP of Denmark in 2005 to that in 2007?
Your answer should be compact. 0.98. What is the ratio of the % of GDP of Mozambique in 2005 to that in 2007?
Provide a succinct answer. 0.45. What is the ratio of the % of GDP of Netherlands in 2005 to that in 2007?
Offer a very short reply. 0.95. What is the ratio of the % of GDP of OECD members in 2005 to that in 2008?
Offer a very short reply. 1.02. What is the ratio of the % of GDP in Denmark in 2005 to that in 2008?
Keep it short and to the point. 1.01. What is the ratio of the % of GDP of Mozambique in 2005 to that in 2008?
Make the answer very short. 0.38. What is the ratio of the % of GDP in Netherlands in 2005 to that in 2008?
Offer a very short reply. 0.96. What is the ratio of the % of GDP of OECD members in 2005 to that in 2009?
Give a very brief answer. 1.13. What is the ratio of the % of GDP of Denmark in 2005 to that in 2009?
Provide a short and direct response. 1.19. What is the ratio of the % of GDP in Mozambique in 2005 to that in 2009?
Ensure brevity in your answer.  0.5. What is the ratio of the % of GDP in Netherlands in 2005 to that in 2009?
Provide a short and direct response. 1.05. What is the ratio of the % of GDP in OECD members in 2005 to that in 2010?
Your answer should be compact. 1.11. What is the ratio of the % of GDP in Denmark in 2005 to that in 2010?
Your answer should be very brief. 1.13. What is the ratio of the % of GDP of Mozambique in 2005 to that in 2010?
Ensure brevity in your answer.  0.4. What is the ratio of the % of GDP in Netherlands in 2005 to that in 2010?
Give a very brief answer. 1.03. What is the ratio of the % of GDP of OECD members in 2006 to that in 2007?
Your response must be concise. 0.99. What is the ratio of the % of GDP in Denmark in 2006 to that in 2007?
Your answer should be compact. 1.01. What is the ratio of the % of GDP in Mozambique in 2006 to that in 2007?
Offer a very short reply. 1.08. What is the ratio of the % of GDP of Netherlands in 2006 to that in 2007?
Ensure brevity in your answer.  0.97. What is the ratio of the % of GDP in OECD members in 2006 to that in 2008?
Your response must be concise. 1.04. What is the ratio of the % of GDP in Denmark in 2006 to that in 2008?
Make the answer very short. 1.04. What is the ratio of the % of GDP of Mozambique in 2006 to that in 2008?
Give a very brief answer. 0.9. What is the ratio of the % of GDP in Netherlands in 2006 to that in 2008?
Your answer should be compact. 0.98. What is the ratio of the % of GDP of OECD members in 2006 to that in 2009?
Your answer should be very brief. 1.15. What is the ratio of the % of GDP in Denmark in 2006 to that in 2009?
Offer a terse response. 1.22. What is the ratio of the % of GDP in Mozambique in 2006 to that in 2009?
Provide a short and direct response. 1.2. What is the ratio of the % of GDP in Netherlands in 2006 to that in 2009?
Your answer should be compact. 1.07. What is the ratio of the % of GDP in OECD members in 2006 to that in 2010?
Offer a terse response. 1.12. What is the ratio of the % of GDP in Denmark in 2006 to that in 2010?
Give a very brief answer. 1.16. What is the ratio of the % of GDP in Mozambique in 2006 to that in 2010?
Your response must be concise. 0.95. What is the ratio of the % of GDP of Netherlands in 2006 to that in 2010?
Your answer should be compact. 1.05. What is the ratio of the % of GDP in OECD members in 2007 to that in 2008?
Keep it short and to the point. 1.05. What is the ratio of the % of GDP of Denmark in 2007 to that in 2008?
Your answer should be compact. 1.03. What is the ratio of the % of GDP in Mozambique in 2007 to that in 2008?
Your answer should be very brief. 0.84. What is the ratio of the % of GDP of Netherlands in 2007 to that in 2008?
Provide a short and direct response. 1. What is the ratio of the % of GDP in OECD members in 2007 to that in 2009?
Provide a succinct answer. 1.16. What is the ratio of the % of GDP in Denmark in 2007 to that in 2009?
Your response must be concise. 1.21. What is the ratio of the % of GDP in Mozambique in 2007 to that in 2009?
Your response must be concise. 1.11. What is the ratio of the % of GDP of Netherlands in 2007 to that in 2009?
Your answer should be very brief. 1.1. What is the ratio of the % of GDP in OECD members in 2007 to that in 2010?
Ensure brevity in your answer.  1.14. What is the ratio of the % of GDP in Denmark in 2007 to that in 2010?
Provide a short and direct response. 1.15. What is the ratio of the % of GDP of Mozambique in 2007 to that in 2010?
Keep it short and to the point. 0.88. What is the ratio of the % of GDP of Netherlands in 2007 to that in 2010?
Offer a very short reply. 1.08. What is the ratio of the % of GDP of OECD members in 2008 to that in 2009?
Keep it short and to the point. 1.11. What is the ratio of the % of GDP in Denmark in 2008 to that in 2009?
Your response must be concise. 1.18. What is the ratio of the % of GDP of Mozambique in 2008 to that in 2009?
Make the answer very short. 1.33. What is the ratio of the % of GDP of Netherlands in 2008 to that in 2009?
Offer a terse response. 1.1. What is the ratio of the % of GDP in OECD members in 2008 to that in 2010?
Ensure brevity in your answer.  1.08. What is the ratio of the % of GDP in Denmark in 2008 to that in 2010?
Provide a succinct answer. 1.12. What is the ratio of the % of GDP in Mozambique in 2008 to that in 2010?
Your response must be concise. 1.05. What is the ratio of the % of GDP of Netherlands in 2008 to that in 2010?
Your answer should be very brief. 1.08. What is the ratio of the % of GDP of OECD members in 2009 to that in 2010?
Keep it short and to the point. 0.98. What is the ratio of the % of GDP in Denmark in 2009 to that in 2010?
Your response must be concise. 0.95. What is the ratio of the % of GDP in Mozambique in 2009 to that in 2010?
Offer a very short reply. 0.79. What is the ratio of the % of GDP in Netherlands in 2009 to that in 2010?
Give a very brief answer. 0.98. What is the difference between the highest and the second highest % of GDP of OECD members?
Your answer should be very brief. 0.28. What is the difference between the highest and the second highest % of GDP in Denmark?
Provide a short and direct response. 0.22. What is the difference between the highest and the second highest % of GDP in Mozambique?
Keep it short and to the point. 0.39. What is the difference between the highest and the second highest % of GDP in Netherlands?
Offer a very short reply. 0.1. What is the difference between the highest and the lowest % of GDP in OECD members?
Your answer should be compact. 3.13. What is the difference between the highest and the lowest % of GDP of Denmark?
Provide a short and direct response. 5.17. What is the difference between the highest and the lowest % of GDP in Mozambique?
Make the answer very short. 7.7. What is the difference between the highest and the lowest % of GDP in Netherlands?
Offer a very short reply. 3.51. 